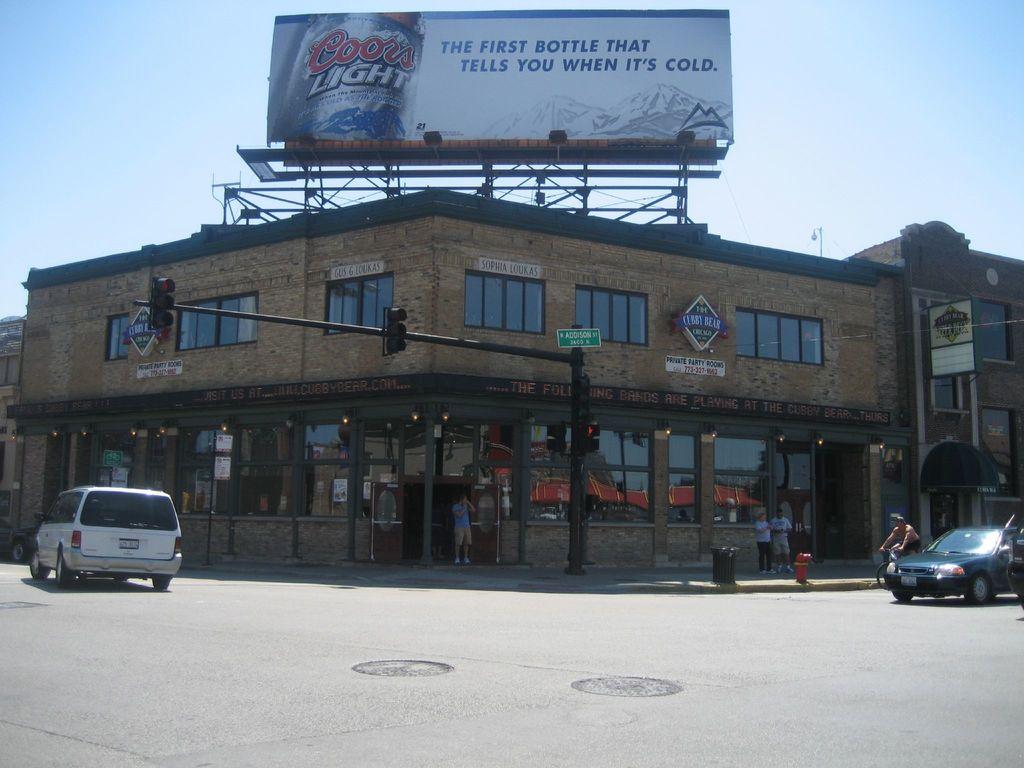What beer is being advertised here?
Provide a succinct answer. Coors light. 